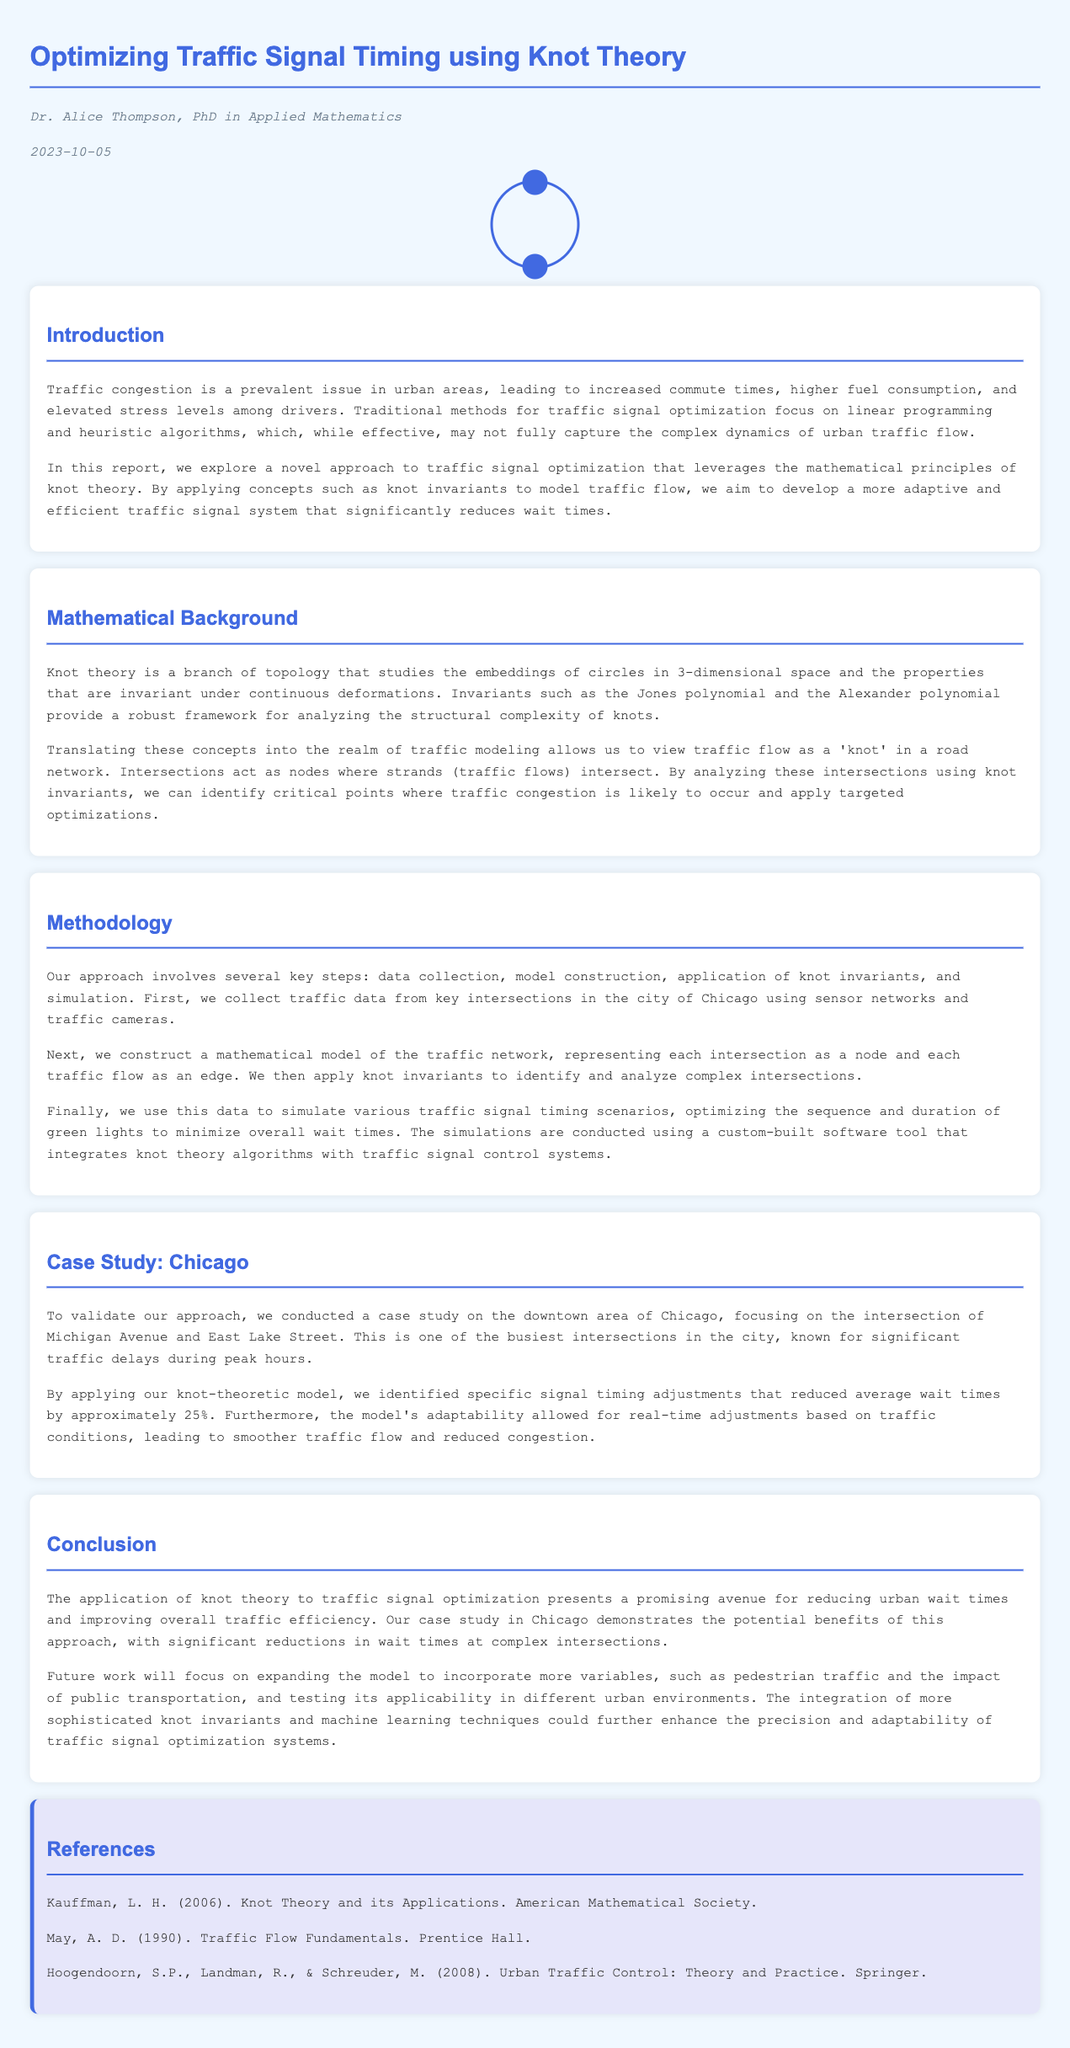What is the title of the report? The title is stated in the header section of the document.
Answer: Optimizing Traffic Signal Timing using Knot Theory Who is the author of the document? The author's name is provided immediately under the title.
Answer: Dr. Alice Thompson When was the report published? The publication date is mentioned just below the author's name.
Answer: 2023-10-05 What percentage reduction in wait times was achieved in the case study? The percentage is given in the case study section describing the results.
Answer: 25% What mathematical field is applied to traffic signal optimization? This information can be found in the introduction and methodology sections discussing the approach.
Answer: Knot theory Which city was used for the case study? The case study section names the specific city where the study was conducted.
Answer: Chicago What are two types of polygons mentioned in the mathematical background? The document discusses certain properties related to knot theory in the Mathematical Background section.
Answer: Jones polynomial and Alexander polynomial What is the primary goal of the report? The introduction outlines the main objective of the research.
Answer: To reduce wait times What is the method used for collecting data in the study? The methodology section describes how data was gathered for the traffic signals.
Answer: Sensor networks and traffic cameras 